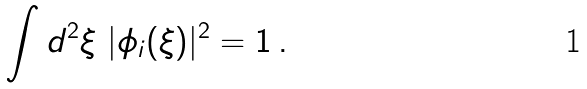Convert formula to latex. <formula><loc_0><loc_0><loc_500><loc_500>\int d ^ { 2 } \xi \ | \phi _ { i } ( \xi ) | ^ { 2 } = 1 \, .</formula> 